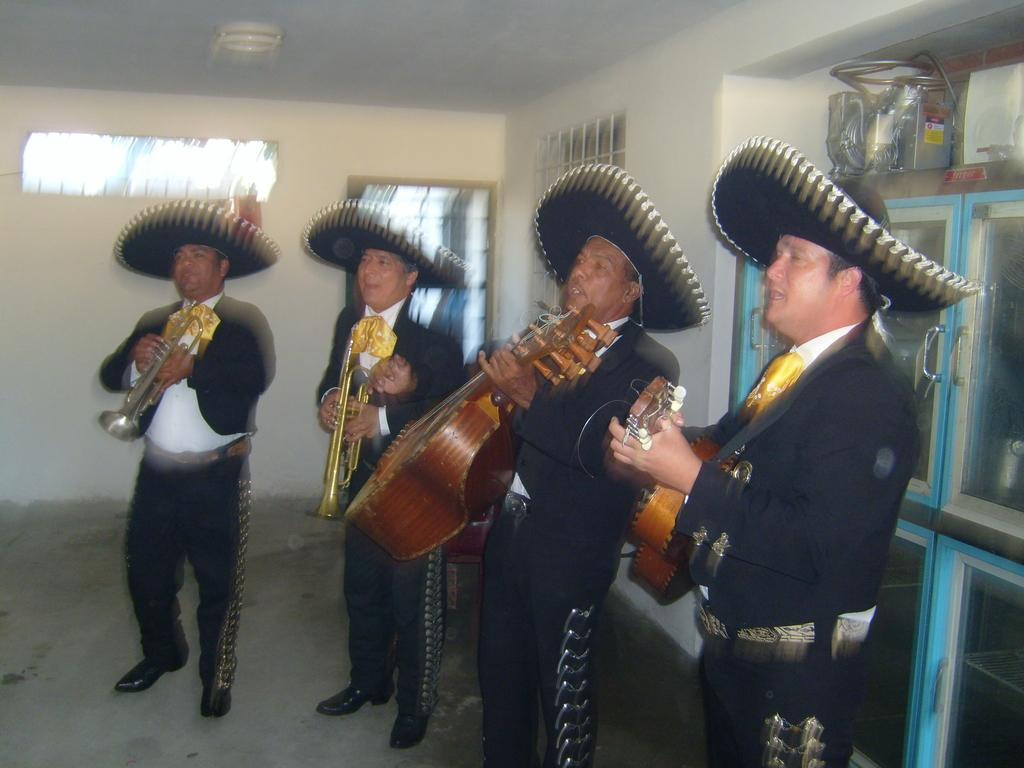How many people are in the image? There are four persons in the image. What are the persons doing in the image? The persons are playing musical instruments. Where are the persons standing in the image? The persons are standing on the floor. What can be seen in the background of the image? There is a wall and a cupboard in the background of the image. How many toothbrushes are visible in the image? There are no toothbrushes present in the image. What type of adjustment can be made to the musical instruments in the image? The question is not relevant to the image, as it does not mention any adjustments to the musical instruments. 